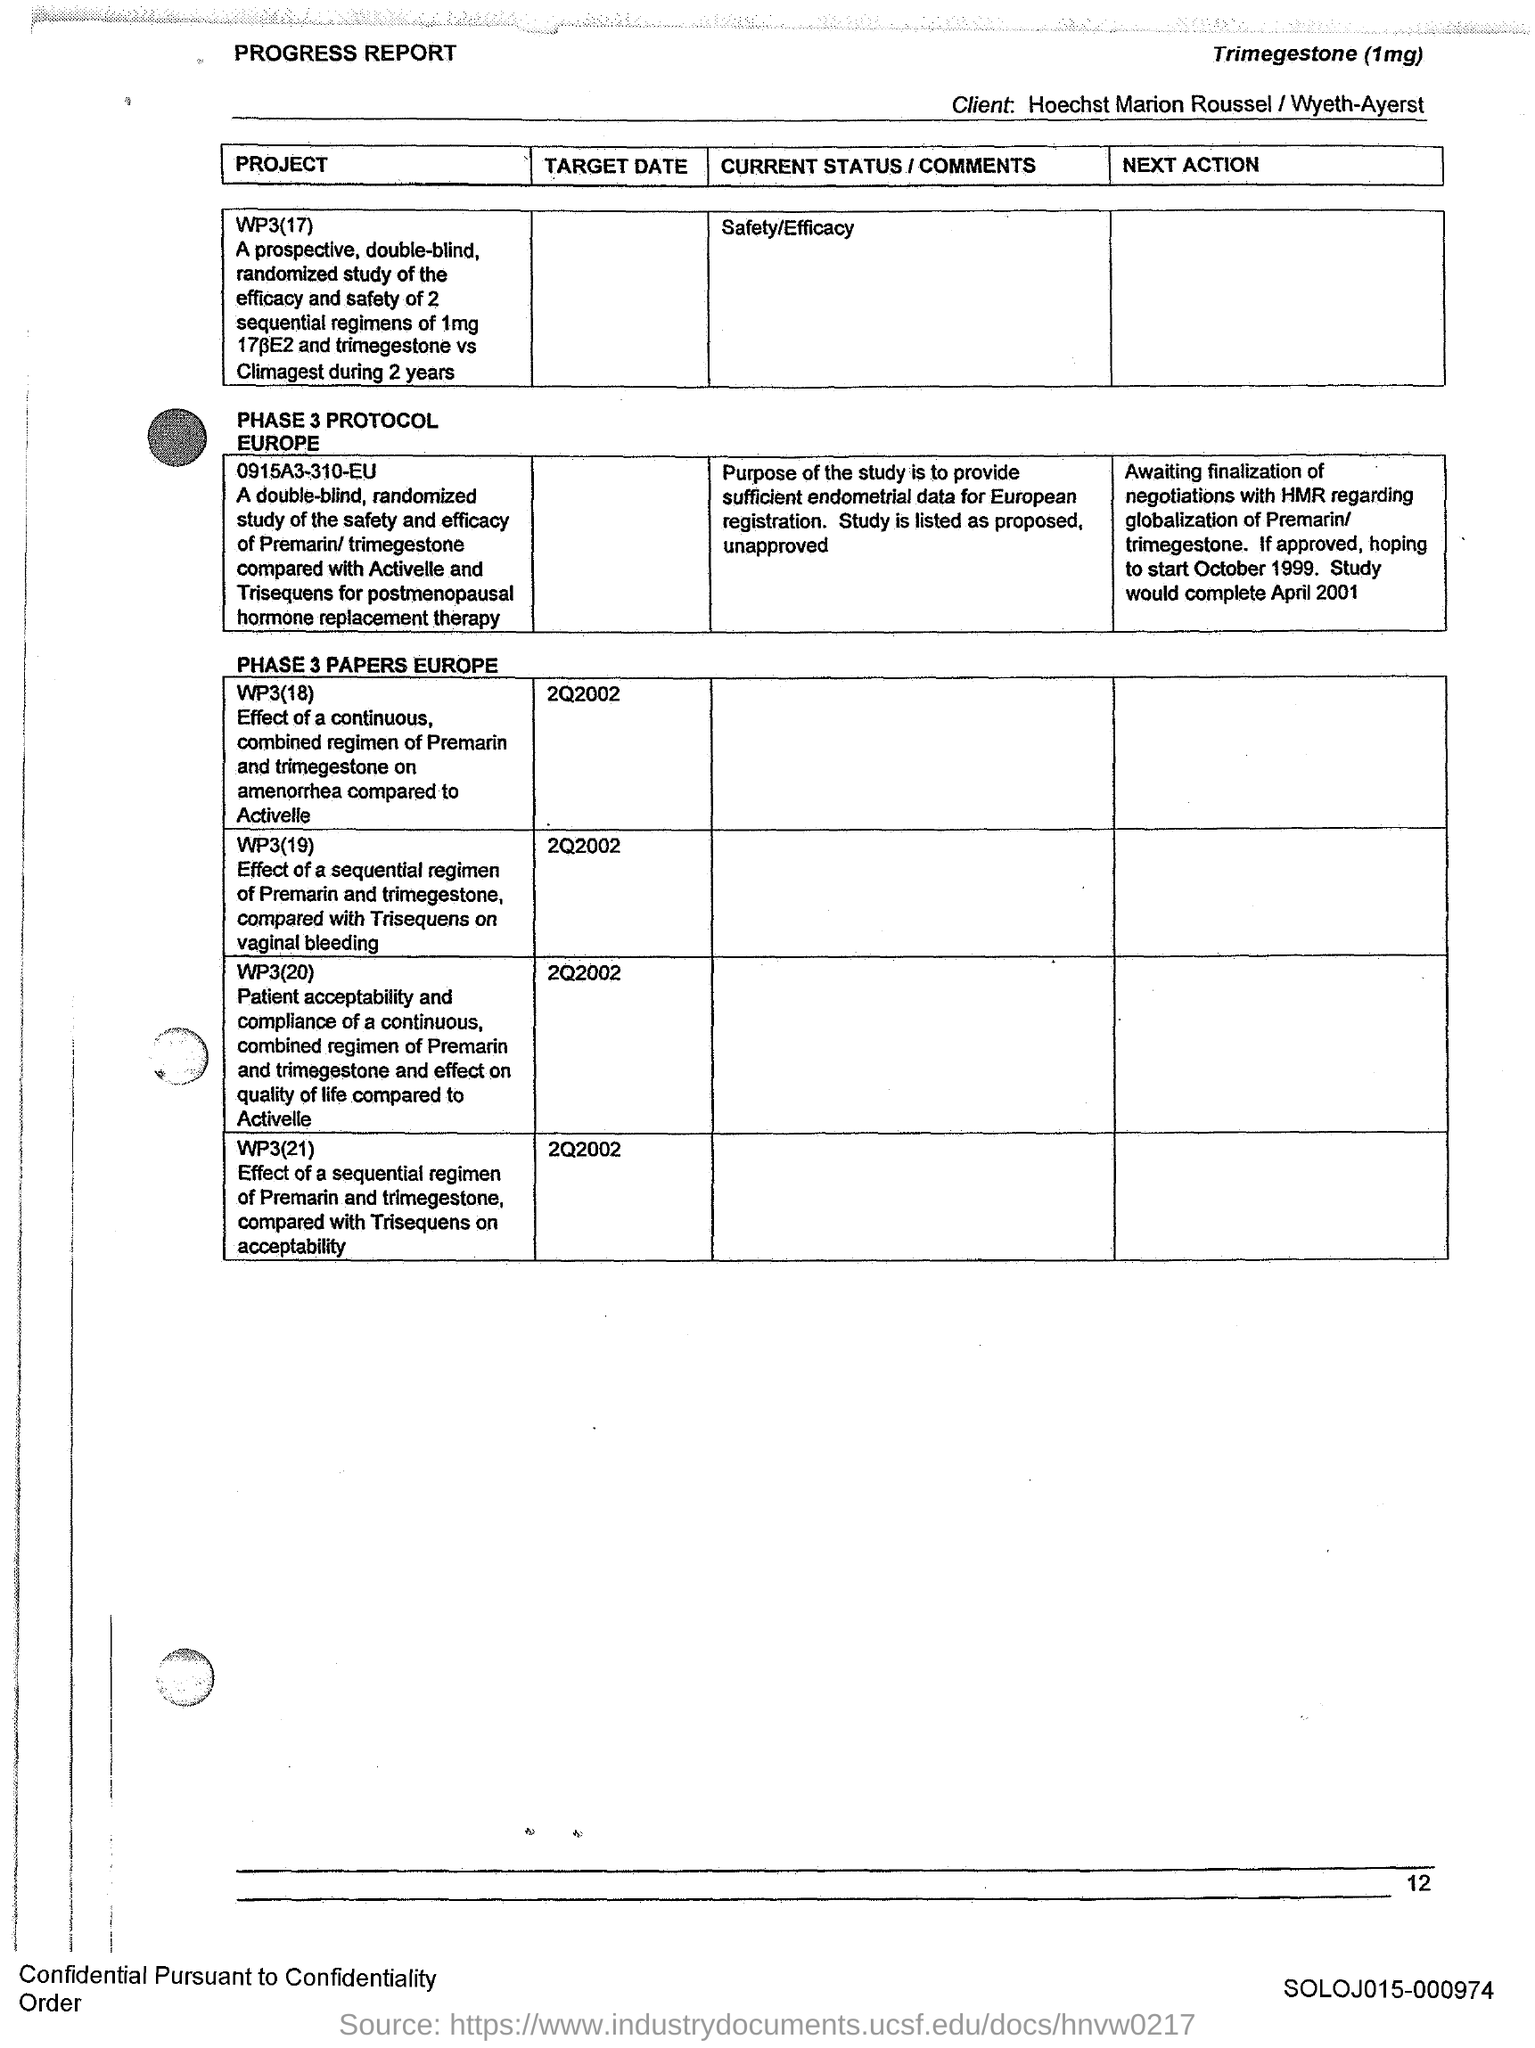Which text is at the top-left of the document?
Provide a succinct answer. Progress Report. Which text is at the top-right of the document?
Make the answer very short. Trimegestone (1mg). 